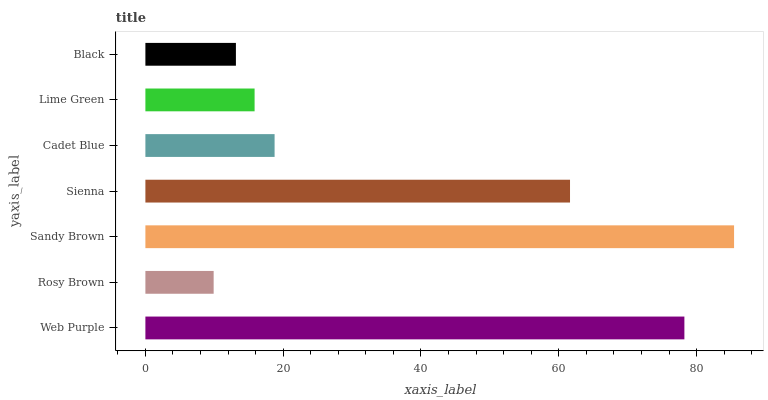Is Rosy Brown the minimum?
Answer yes or no. Yes. Is Sandy Brown the maximum?
Answer yes or no. Yes. Is Sandy Brown the minimum?
Answer yes or no. No. Is Rosy Brown the maximum?
Answer yes or no. No. Is Sandy Brown greater than Rosy Brown?
Answer yes or no. Yes. Is Rosy Brown less than Sandy Brown?
Answer yes or no. Yes. Is Rosy Brown greater than Sandy Brown?
Answer yes or no. No. Is Sandy Brown less than Rosy Brown?
Answer yes or no. No. Is Cadet Blue the high median?
Answer yes or no. Yes. Is Cadet Blue the low median?
Answer yes or no. Yes. Is Sandy Brown the high median?
Answer yes or no. No. Is Rosy Brown the low median?
Answer yes or no. No. 